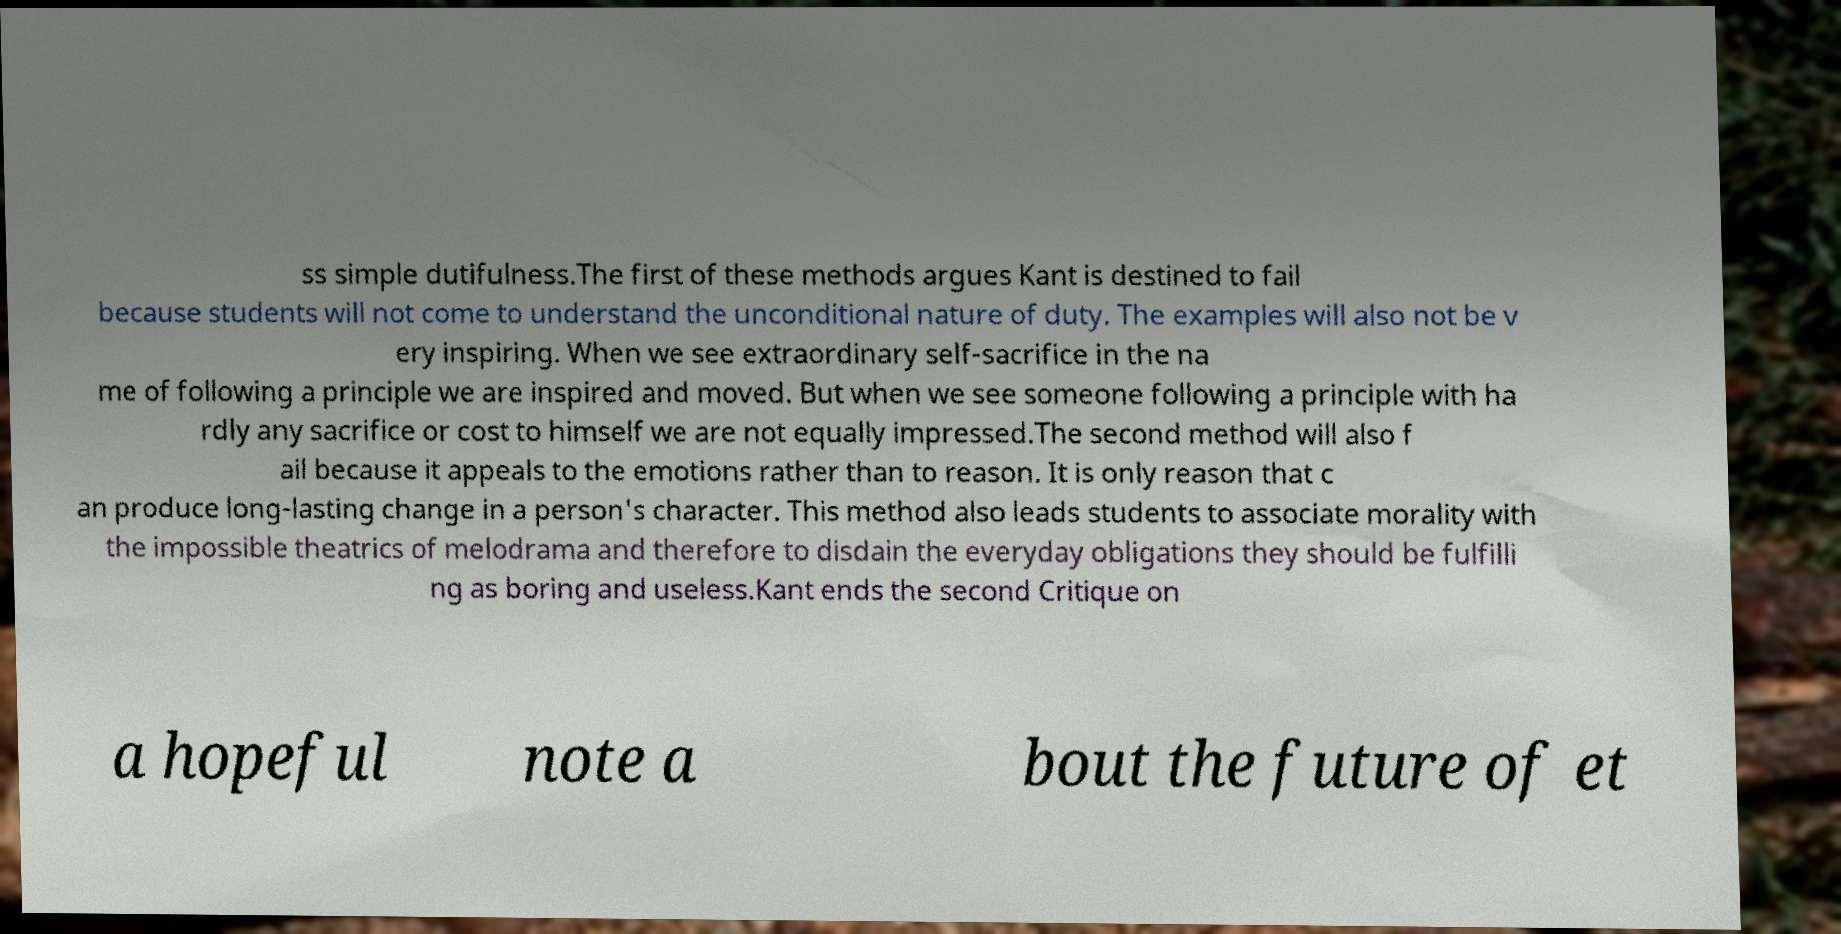Can you read and provide the text displayed in the image?This photo seems to have some interesting text. Can you extract and type it out for me? ss simple dutifulness.The first of these methods argues Kant is destined to fail because students will not come to understand the unconditional nature of duty. The examples will also not be v ery inspiring. When we see extraordinary self-sacrifice in the na me of following a principle we are inspired and moved. But when we see someone following a principle with ha rdly any sacrifice or cost to himself we are not equally impressed.The second method will also f ail because it appeals to the emotions rather than to reason. It is only reason that c an produce long-lasting change in a person's character. This method also leads students to associate morality with the impossible theatrics of melodrama and therefore to disdain the everyday obligations they should be fulfilli ng as boring and useless.Kant ends the second Critique on a hopeful note a bout the future of et 